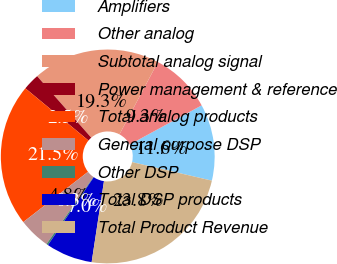<chart> <loc_0><loc_0><loc_500><loc_500><pie_chart><fcel>Amplifiers<fcel>Other analog<fcel>Subtotal analog signal<fcel>Power management & reference<fcel>Total analog products<fcel>General purpose DSP<fcel>Other DSP<fcel>Total DSP products<fcel>Total Product Revenue<nl><fcel>11.56%<fcel>9.3%<fcel>19.25%<fcel>2.52%<fcel>21.51%<fcel>4.78%<fcel>0.26%<fcel>7.04%<fcel>23.77%<nl></chart> 